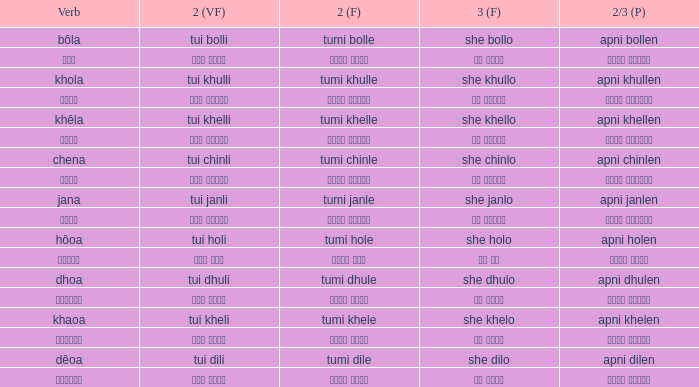What is the 2nd verb for Khola? Tumi khulle. 